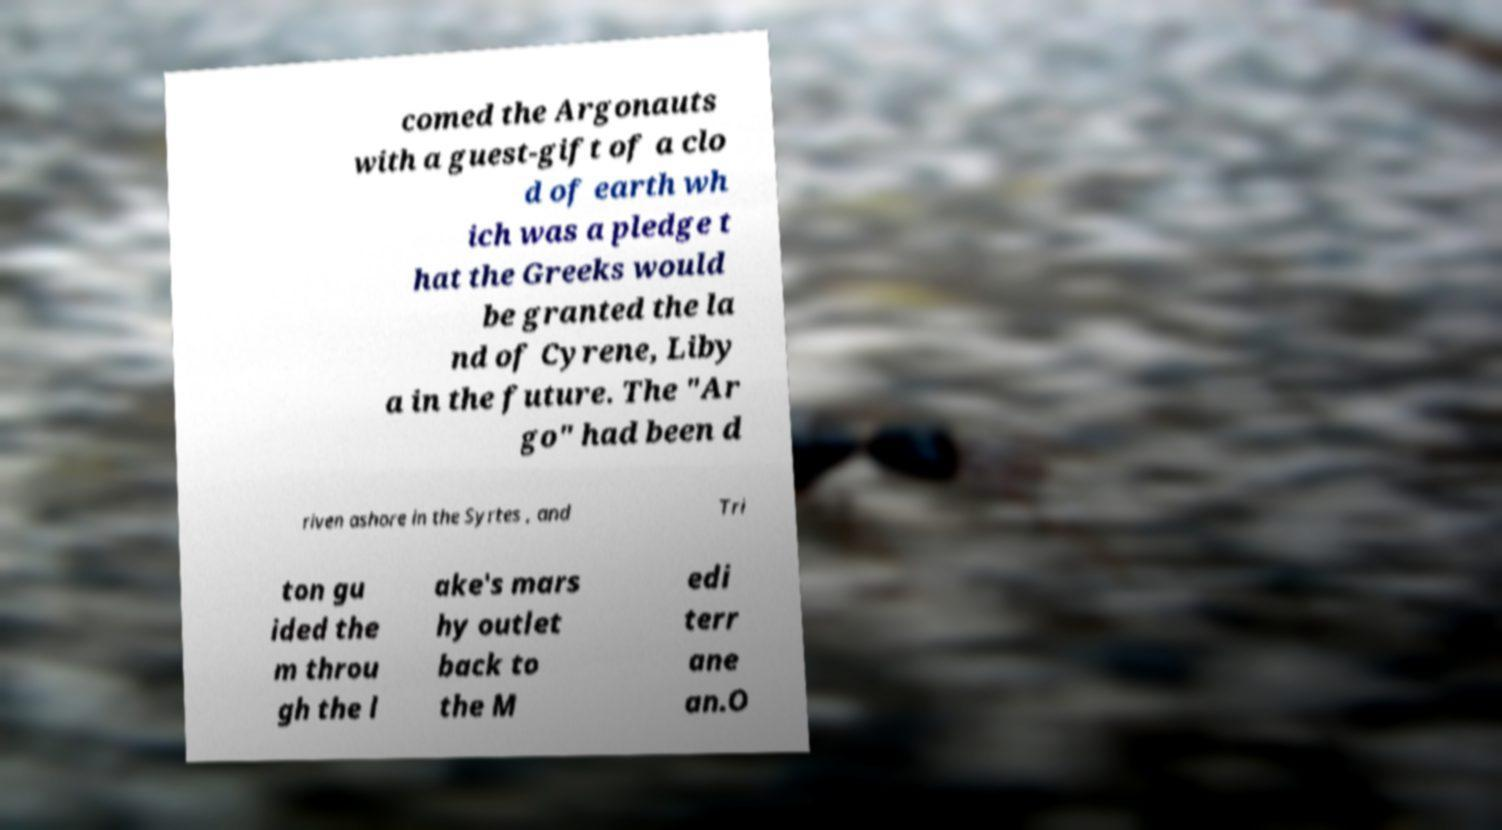There's text embedded in this image that I need extracted. Can you transcribe it verbatim? comed the Argonauts with a guest-gift of a clo d of earth wh ich was a pledge t hat the Greeks would be granted the la nd of Cyrene, Liby a in the future. The "Ar go" had been d riven ashore in the Syrtes , and Tri ton gu ided the m throu gh the l ake's mars hy outlet back to the M edi terr ane an.O 